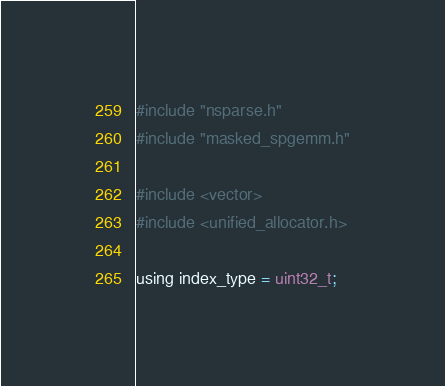<code> <loc_0><loc_0><loc_500><loc_500><_Cuda_>#include "nsparse.h"
#include "masked_spgemm.h"

#include <vector>
#include <unified_allocator.h>

using index_type = uint32_t;</code> 